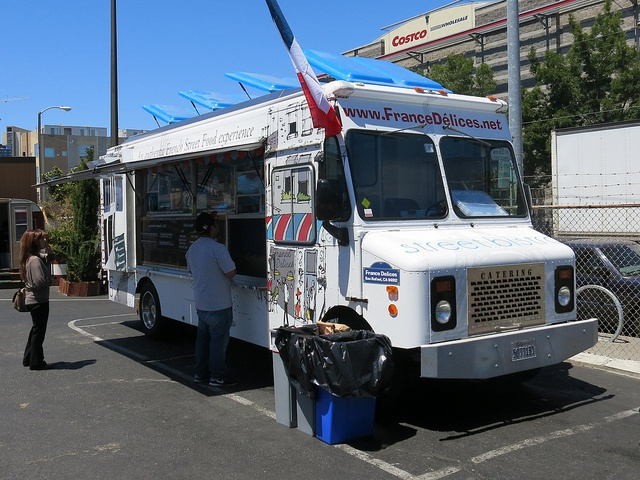Describe the objects in this image and their specific colors. I can see truck in lightblue, black, lightgray, gray, and darkgray tones, truck in lightblue, lightgray, darkgray, gray, and black tones, people in lightblue, black, darkblue, navy, and gray tones, car in lightblue, black, gray, and darkgray tones, and people in lightblue, black, gray, and maroon tones in this image. 